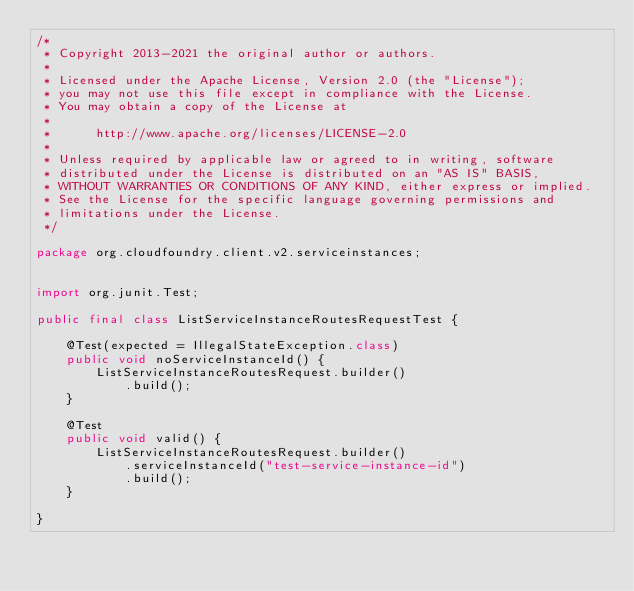Convert code to text. <code><loc_0><loc_0><loc_500><loc_500><_Java_>/*
 * Copyright 2013-2021 the original author or authors.
 *
 * Licensed under the Apache License, Version 2.0 (the "License");
 * you may not use this file except in compliance with the License.
 * You may obtain a copy of the License at
 *
 *      http://www.apache.org/licenses/LICENSE-2.0
 *
 * Unless required by applicable law or agreed to in writing, software
 * distributed under the License is distributed on an "AS IS" BASIS,
 * WITHOUT WARRANTIES OR CONDITIONS OF ANY KIND, either express or implied.
 * See the License for the specific language governing permissions and
 * limitations under the License.
 */

package org.cloudfoundry.client.v2.serviceinstances;


import org.junit.Test;

public final class ListServiceInstanceRoutesRequestTest {

    @Test(expected = IllegalStateException.class)
    public void noServiceInstanceId() {
        ListServiceInstanceRoutesRequest.builder()
            .build();
    }

    @Test
    public void valid() {
        ListServiceInstanceRoutesRequest.builder()
            .serviceInstanceId("test-service-instance-id")
            .build();
    }

}
</code> 